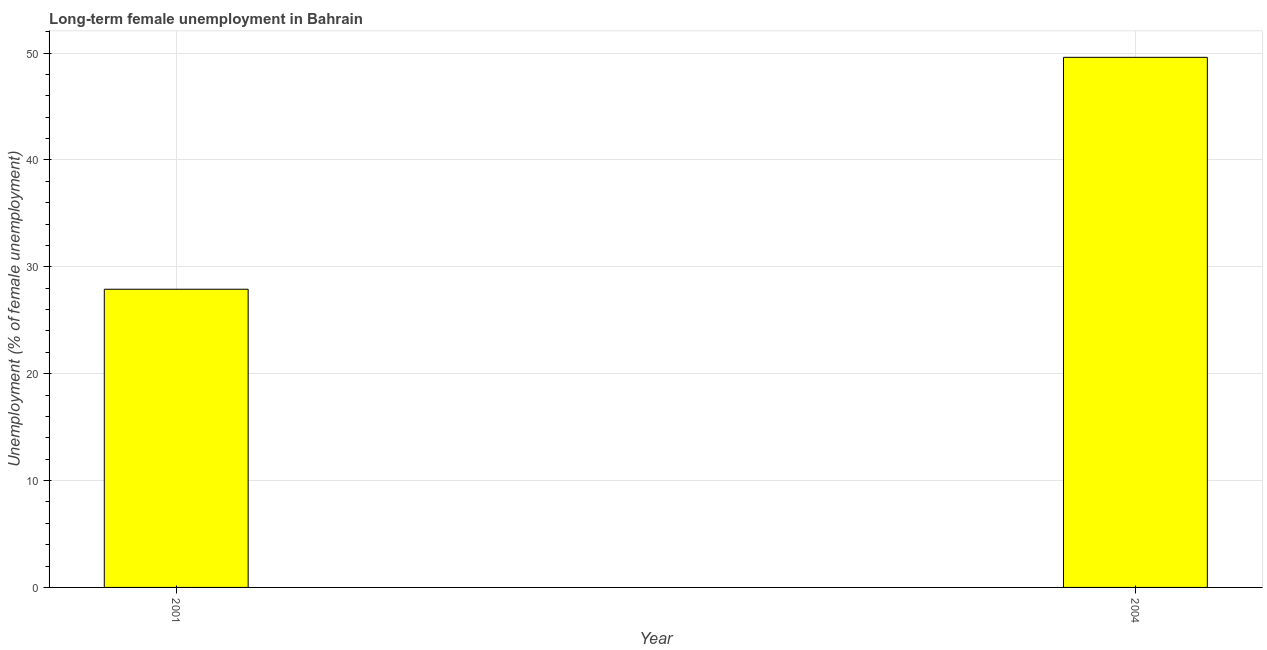Does the graph contain any zero values?
Ensure brevity in your answer.  No. What is the title of the graph?
Provide a succinct answer. Long-term female unemployment in Bahrain. What is the label or title of the X-axis?
Your answer should be very brief. Year. What is the label or title of the Y-axis?
Give a very brief answer. Unemployment (% of female unemployment). What is the long-term female unemployment in 2004?
Your answer should be very brief. 49.6. Across all years, what is the maximum long-term female unemployment?
Provide a short and direct response. 49.6. Across all years, what is the minimum long-term female unemployment?
Provide a succinct answer. 27.9. In which year was the long-term female unemployment minimum?
Give a very brief answer. 2001. What is the sum of the long-term female unemployment?
Offer a very short reply. 77.5. What is the difference between the long-term female unemployment in 2001 and 2004?
Your answer should be very brief. -21.7. What is the average long-term female unemployment per year?
Your answer should be compact. 38.75. What is the median long-term female unemployment?
Provide a short and direct response. 38.75. Do a majority of the years between 2001 and 2004 (inclusive) have long-term female unemployment greater than 8 %?
Give a very brief answer. Yes. What is the ratio of the long-term female unemployment in 2001 to that in 2004?
Your answer should be compact. 0.56. Is the long-term female unemployment in 2001 less than that in 2004?
Your answer should be compact. Yes. What is the difference between two consecutive major ticks on the Y-axis?
Provide a succinct answer. 10. Are the values on the major ticks of Y-axis written in scientific E-notation?
Provide a succinct answer. No. What is the Unemployment (% of female unemployment) in 2001?
Keep it short and to the point. 27.9. What is the Unemployment (% of female unemployment) in 2004?
Offer a terse response. 49.6. What is the difference between the Unemployment (% of female unemployment) in 2001 and 2004?
Make the answer very short. -21.7. What is the ratio of the Unemployment (% of female unemployment) in 2001 to that in 2004?
Provide a short and direct response. 0.56. 